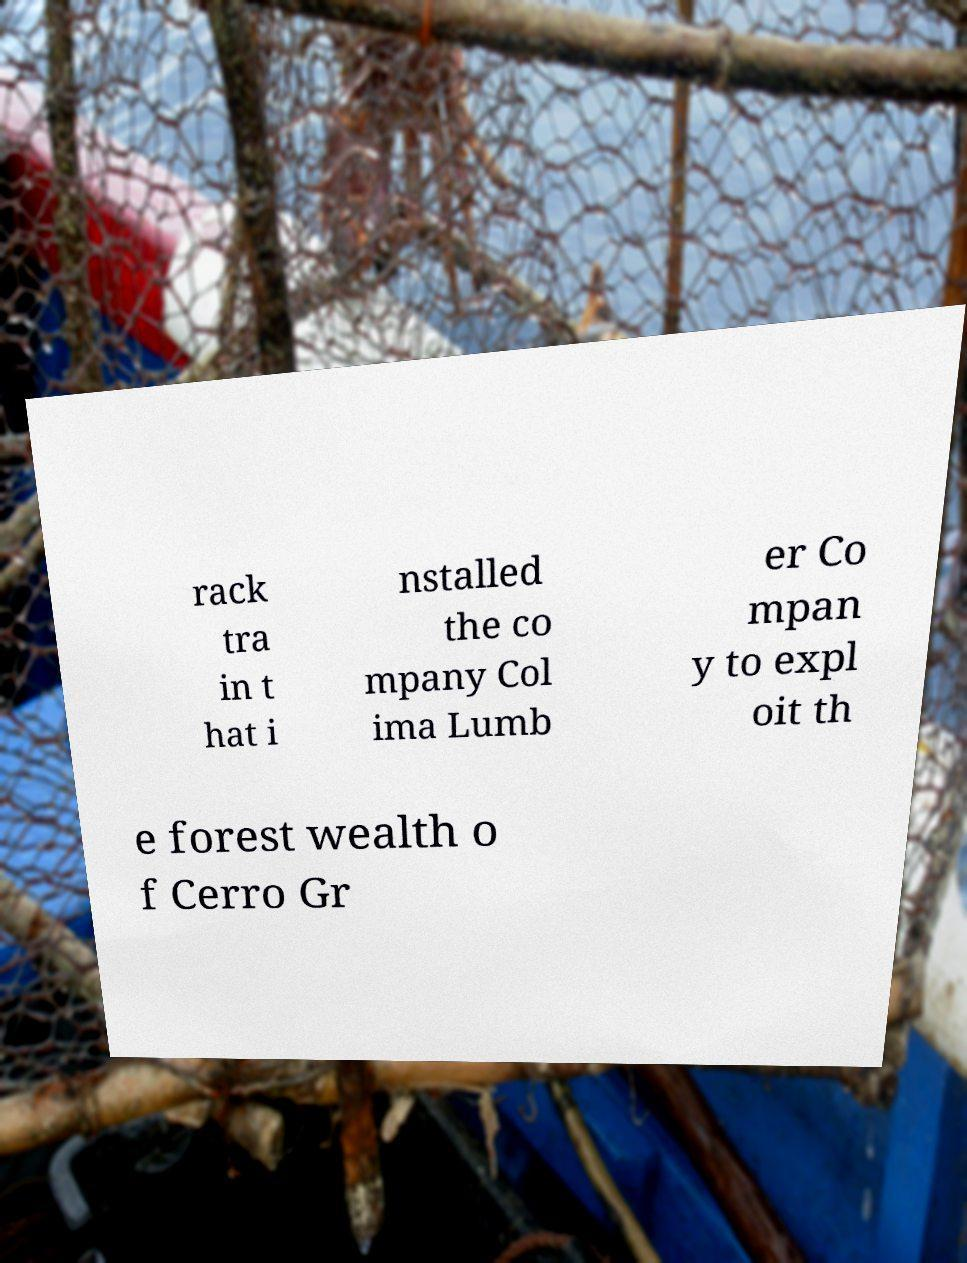There's text embedded in this image that I need extracted. Can you transcribe it verbatim? rack tra in t hat i nstalled the co mpany Col ima Lumb er Co mpan y to expl oit th e forest wealth o f Cerro Gr 